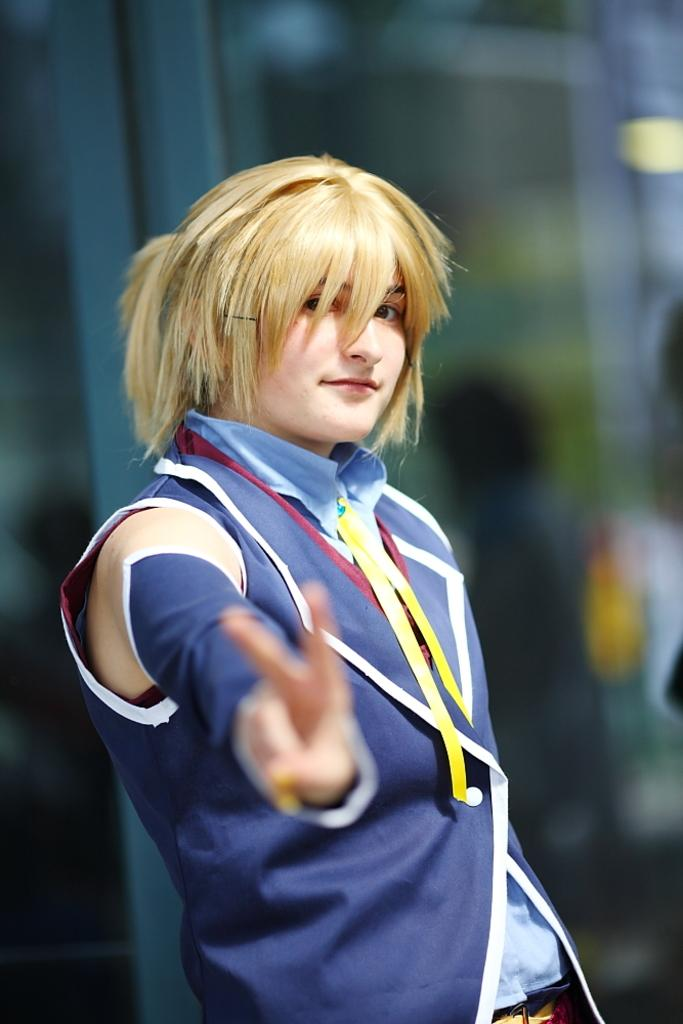Who is the main subject in the image? There is a woman in the image. What is the woman wearing? The woman is wearing a red dress. What expression does the woman have? The woman is smiling. Can you describe the background of the image? The background of the image is blurred. What time of day is it in the image, and how does the woman pull the sun up? The time of day is not mentioned in the image, and there is no indication of the woman pulling the sun up. 